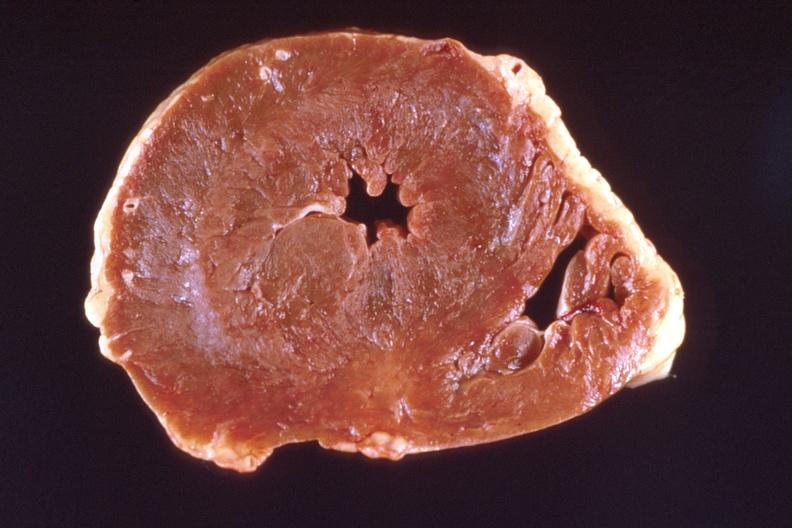s marked left ventricular hypertrophy?
Answer the question using a single word or phrase. Yes 